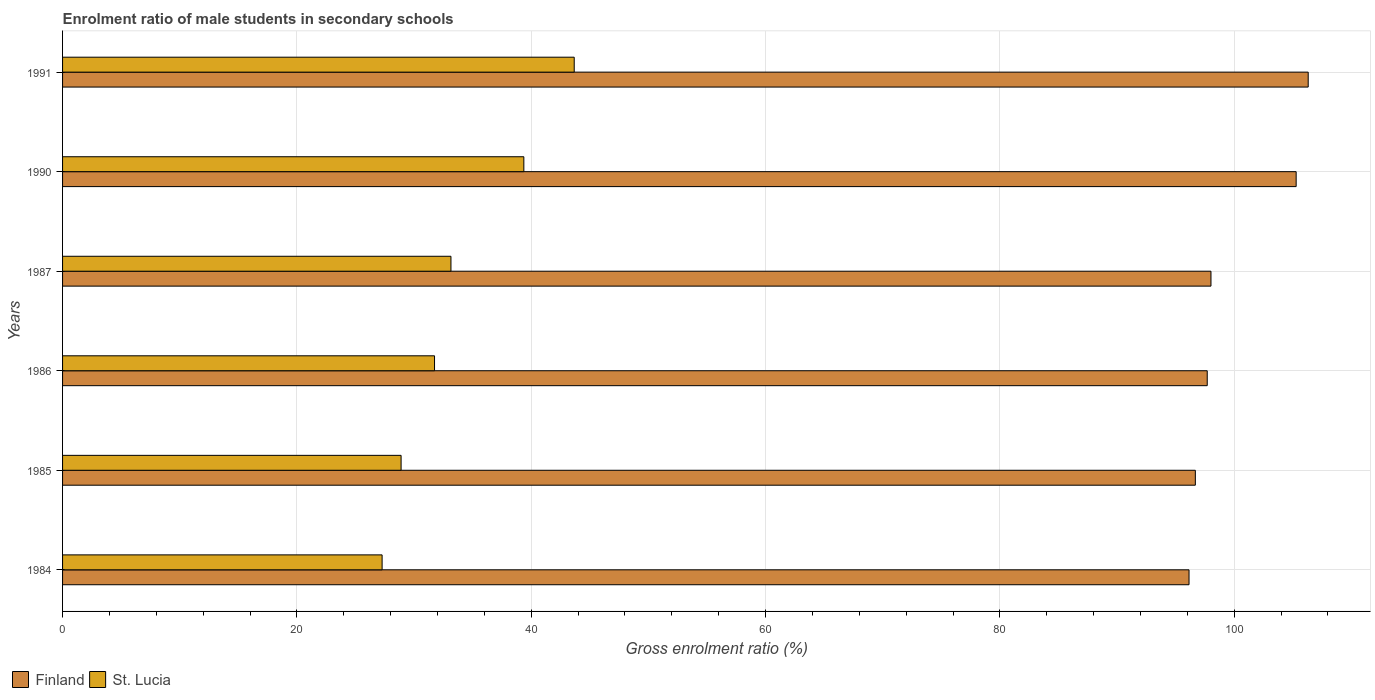How many different coloured bars are there?
Keep it short and to the point. 2. How many groups of bars are there?
Provide a short and direct response. 6. How many bars are there on the 5th tick from the top?
Ensure brevity in your answer.  2. How many bars are there on the 5th tick from the bottom?
Provide a succinct answer. 2. What is the enrolment ratio of male students in secondary schools in St. Lucia in 1990?
Provide a succinct answer. 39.37. Across all years, what is the maximum enrolment ratio of male students in secondary schools in St. Lucia?
Keep it short and to the point. 43.67. Across all years, what is the minimum enrolment ratio of male students in secondary schools in Finland?
Give a very brief answer. 96.14. In which year was the enrolment ratio of male students in secondary schools in Finland minimum?
Provide a short and direct response. 1984. What is the total enrolment ratio of male students in secondary schools in St. Lucia in the graph?
Your answer should be compact. 204.1. What is the difference between the enrolment ratio of male students in secondary schools in Finland in 1984 and that in 1985?
Your answer should be very brief. -0.54. What is the difference between the enrolment ratio of male students in secondary schools in St. Lucia in 1991 and the enrolment ratio of male students in secondary schools in Finland in 1985?
Ensure brevity in your answer.  -53.01. What is the average enrolment ratio of male students in secondary schools in St. Lucia per year?
Make the answer very short. 34.02. In the year 1985, what is the difference between the enrolment ratio of male students in secondary schools in St. Lucia and enrolment ratio of male students in secondary schools in Finland?
Make the answer very short. -67.79. In how many years, is the enrolment ratio of male students in secondary schools in Finland greater than 20 %?
Give a very brief answer. 6. What is the ratio of the enrolment ratio of male students in secondary schools in St. Lucia in 1985 to that in 1990?
Ensure brevity in your answer.  0.73. Is the enrolment ratio of male students in secondary schools in St. Lucia in 1986 less than that in 1991?
Ensure brevity in your answer.  Yes. What is the difference between the highest and the second highest enrolment ratio of male students in secondary schools in St. Lucia?
Keep it short and to the point. 4.3. What is the difference between the highest and the lowest enrolment ratio of male students in secondary schools in St. Lucia?
Provide a succinct answer. 16.4. In how many years, is the enrolment ratio of male students in secondary schools in Finland greater than the average enrolment ratio of male students in secondary schools in Finland taken over all years?
Your response must be concise. 2. Is the sum of the enrolment ratio of male students in secondary schools in Finland in 1984 and 1991 greater than the maximum enrolment ratio of male students in secondary schools in St. Lucia across all years?
Your answer should be compact. Yes. What does the 1st bar from the top in 1986 represents?
Your answer should be very brief. St. Lucia. What does the 2nd bar from the bottom in 1985 represents?
Offer a very short reply. St. Lucia. How many years are there in the graph?
Offer a terse response. 6. Does the graph contain any zero values?
Keep it short and to the point. No. Where does the legend appear in the graph?
Offer a terse response. Bottom left. What is the title of the graph?
Make the answer very short. Enrolment ratio of male students in secondary schools. What is the label or title of the Y-axis?
Ensure brevity in your answer.  Years. What is the Gross enrolment ratio (%) in Finland in 1984?
Keep it short and to the point. 96.14. What is the Gross enrolment ratio (%) in St. Lucia in 1984?
Offer a very short reply. 27.27. What is the Gross enrolment ratio (%) in Finland in 1985?
Provide a short and direct response. 96.68. What is the Gross enrolment ratio (%) in St. Lucia in 1985?
Make the answer very short. 28.89. What is the Gross enrolment ratio (%) in Finland in 1986?
Provide a succinct answer. 97.7. What is the Gross enrolment ratio (%) of St. Lucia in 1986?
Make the answer very short. 31.75. What is the Gross enrolment ratio (%) in Finland in 1987?
Offer a terse response. 98.01. What is the Gross enrolment ratio (%) of St. Lucia in 1987?
Your answer should be very brief. 33.15. What is the Gross enrolment ratio (%) of Finland in 1990?
Make the answer very short. 105.29. What is the Gross enrolment ratio (%) of St. Lucia in 1990?
Your answer should be compact. 39.37. What is the Gross enrolment ratio (%) in Finland in 1991?
Offer a very short reply. 106.31. What is the Gross enrolment ratio (%) in St. Lucia in 1991?
Ensure brevity in your answer.  43.67. Across all years, what is the maximum Gross enrolment ratio (%) in Finland?
Keep it short and to the point. 106.31. Across all years, what is the maximum Gross enrolment ratio (%) of St. Lucia?
Your answer should be compact. 43.67. Across all years, what is the minimum Gross enrolment ratio (%) of Finland?
Keep it short and to the point. 96.14. Across all years, what is the minimum Gross enrolment ratio (%) in St. Lucia?
Your answer should be compact. 27.27. What is the total Gross enrolment ratio (%) in Finland in the graph?
Offer a terse response. 600.13. What is the total Gross enrolment ratio (%) of St. Lucia in the graph?
Your answer should be compact. 204.1. What is the difference between the Gross enrolment ratio (%) in Finland in 1984 and that in 1985?
Your response must be concise. -0.54. What is the difference between the Gross enrolment ratio (%) of St. Lucia in 1984 and that in 1985?
Your answer should be very brief. -1.62. What is the difference between the Gross enrolment ratio (%) in Finland in 1984 and that in 1986?
Keep it short and to the point. -1.55. What is the difference between the Gross enrolment ratio (%) in St. Lucia in 1984 and that in 1986?
Provide a succinct answer. -4.47. What is the difference between the Gross enrolment ratio (%) in Finland in 1984 and that in 1987?
Give a very brief answer. -1.87. What is the difference between the Gross enrolment ratio (%) in St. Lucia in 1984 and that in 1987?
Provide a succinct answer. -5.88. What is the difference between the Gross enrolment ratio (%) in Finland in 1984 and that in 1990?
Ensure brevity in your answer.  -9.14. What is the difference between the Gross enrolment ratio (%) in St. Lucia in 1984 and that in 1990?
Provide a succinct answer. -12.1. What is the difference between the Gross enrolment ratio (%) in Finland in 1984 and that in 1991?
Give a very brief answer. -10.17. What is the difference between the Gross enrolment ratio (%) of St. Lucia in 1984 and that in 1991?
Your answer should be very brief. -16.4. What is the difference between the Gross enrolment ratio (%) of Finland in 1985 and that in 1986?
Provide a short and direct response. -1.02. What is the difference between the Gross enrolment ratio (%) in St. Lucia in 1985 and that in 1986?
Keep it short and to the point. -2.85. What is the difference between the Gross enrolment ratio (%) of Finland in 1985 and that in 1987?
Keep it short and to the point. -1.33. What is the difference between the Gross enrolment ratio (%) of St. Lucia in 1985 and that in 1987?
Ensure brevity in your answer.  -4.25. What is the difference between the Gross enrolment ratio (%) in Finland in 1985 and that in 1990?
Your response must be concise. -8.6. What is the difference between the Gross enrolment ratio (%) in St. Lucia in 1985 and that in 1990?
Provide a short and direct response. -10.48. What is the difference between the Gross enrolment ratio (%) of Finland in 1985 and that in 1991?
Offer a very short reply. -9.63. What is the difference between the Gross enrolment ratio (%) of St. Lucia in 1985 and that in 1991?
Give a very brief answer. -14.78. What is the difference between the Gross enrolment ratio (%) in Finland in 1986 and that in 1987?
Your answer should be compact. -0.32. What is the difference between the Gross enrolment ratio (%) of St. Lucia in 1986 and that in 1987?
Make the answer very short. -1.4. What is the difference between the Gross enrolment ratio (%) in Finland in 1986 and that in 1990?
Make the answer very short. -7.59. What is the difference between the Gross enrolment ratio (%) of St. Lucia in 1986 and that in 1990?
Make the answer very short. -7.62. What is the difference between the Gross enrolment ratio (%) in Finland in 1986 and that in 1991?
Your response must be concise. -8.62. What is the difference between the Gross enrolment ratio (%) in St. Lucia in 1986 and that in 1991?
Your answer should be compact. -11.92. What is the difference between the Gross enrolment ratio (%) of Finland in 1987 and that in 1990?
Make the answer very short. -7.27. What is the difference between the Gross enrolment ratio (%) in St. Lucia in 1987 and that in 1990?
Offer a very short reply. -6.22. What is the difference between the Gross enrolment ratio (%) in Finland in 1987 and that in 1991?
Your answer should be compact. -8.3. What is the difference between the Gross enrolment ratio (%) in St. Lucia in 1987 and that in 1991?
Make the answer very short. -10.52. What is the difference between the Gross enrolment ratio (%) in Finland in 1990 and that in 1991?
Give a very brief answer. -1.03. What is the difference between the Gross enrolment ratio (%) in St. Lucia in 1990 and that in 1991?
Make the answer very short. -4.3. What is the difference between the Gross enrolment ratio (%) of Finland in 1984 and the Gross enrolment ratio (%) of St. Lucia in 1985?
Provide a succinct answer. 67.25. What is the difference between the Gross enrolment ratio (%) in Finland in 1984 and the Gross enrolment ratio (%) in St. Lucia in 1986?
Offer a terse response. 64.4. What is the difference between the Gross enrolment ratio (%) of Finland in 1984 and the Gross enrolment ratio (%) of St. Lucia in 1987?
Your answer should be very brief. 62.99. What is the difference between the Gross enrolment ratio (%) of Finland in 1984 and the Gross enrolment ratio (%) of St. Lucia in 1990?
Provide a short and direct response. 56.77. What is the difference between the Gross enrolment ratio (%) in Finland in 1984 and the Gross enrolment ratio (%) in St. Lucia in 1991?
Ensure brevity in your answer.  52.47. What is the difference between the Gross enrolment ratio (%) of Finland in 1985 and the Gross enrolment ratio (%) of St. Lucia in 1986?
Your response must be concise. 64.93. What is the difference between the Gross enrolment ratio (%) in Finland in 1985 and the Gross enrolment ratio (%) in St. Lucia in 1987?
Keep it short and to the point. 63.53. What is the difference between the Gross enrolment ratio (%) of Finland in 1985 and the Gross enrolment ratio (%) of St. Lucia in 1990?
Your answer should be very brief. 57.31. What is the difference between the Gross enrolment ratio (%) in Finland in 1985 and the Gross enrolment ratio (%) in St. Lucia in 1991?
Offer a very short reply. 53.01. What is the difference between the Gross enrolment ratio (%) in Finland in 1986 and the Gross enrolment ratio (%) in St. Lucia in 1987?
Ensure brevity in your answer.  64.55. What is the difference between the Gross enrolment ratio (%) of Finland in 1986 and the Gross enrolment ratio (%) of St. Lucia in 1990?
Give a very brief answer. 58.33. What is the difference between the Gross enrolment ratio (%) in Finland in 1986 and the Gross enrolment ratio (%) in St. Lucia in 1991?
Your response must be concise. 54.03. What is the difference between the Gross enrolment ratio (%) of Finland in 1987 and the Gross enrolment ratio (%) of St. Lucia in 1990?
Keep it short and to the point. 58.64. What is the difference between the Gross enrolment ratio (%) in Finland in 1987 and the Gross enrolment ratio (%) in St. Lucia in 1991?
Provide a succinct answer. 54.35. What is the difference between the Gross enrolment ratio (%) of Finland in 1990 and the Gross enrolment ratio (%) of St. Lucia in 1991?
Give a very brief answer. 61.62. What is the average Gross enrolment ratio (%) of Finland per year?
Offer a terse response. 100.02. What is the average Gross enrolment ratio (%) in St. Lucia per year?
Ensure brevity in your answer.  34.02. In the year 1984, what is the difference between the Gross enrolment ratio (%) of Finland and Gross enrolment ratio (%) of St. Lucia?
Your answer should be compact. 68.87. In the year 1985, what is the difference between the Gross enrolment ratio (%) of Finland and Gross enrolment ratio (%) of St. Lucia?
Provide a succinct answer. 67.79. In the year 1986, what is the difference between the Gross enrolment ratio (%) of Finland and Gross enrolment ratio (%) of St. Lucia?
Provide a succinct answer. 65.95. In the year 1987, what is the difference between the Gross enrolment ratio (%) in Finland and Gross enrolment ratio (%) in St. Lucia?
Keep it short and to the point. 64.87. In the year 1990, what is the difference between the Gross enrolment ratio (%) of Finland and Gross enrolment ratio (%) of St. Lucia?
Keep it short and to the point. 65.92. In the year 1991, what is the difference between the Gross enrolment ratio (%) of Finland and Gross enrolment ratio (%) of St. Lucia?
Offer a terse response. 62.65. What is the ratio of the Gross enrolment ratio (%) of St. Lucia in 1984 to that in 1985?
Give a very brief answer. 0.94. What is the ratio of the Gross enrolment ratio (%) in Finland in 1984 to that in 1986?
Provide a succinct answer. 0.98. What is the ratio of the Gross enrolment ratio (%) of St. Lucia in 1984 to that in 1986?
Provide a short and direct response. 0.86. What is the ratio of the Gross enrolment ratio (%) in Finland in 1984 to that in 1987?
Give a very brief answer. 0.98. What is the ratio of the Gross enrolment ratio (%) in St. Lucia in 1984 to that in 1987?
Offer a terse response. 0.82. What is the ratio of the Gross enrolment ratio (%) of Finland in 1984 to that in 1990?
Ensure brevity in your answer.  0.91. What is the ratio of the Gross enrolment ratio (%) in St. Lucia in 1984 to that in 1990?
Provide a short and direct response. 0.69. What is the ratio of the Gross enrolment ratio (%) in Finland in 1984 to that in 1991?
Give a very brief answer. 0.9. What is the ratio of the Gross enrolment ratio (%) of St. Lucia in 1984 to that in 1991?
Offer a terse response. 0.62. What is the ratio of the Gross enrolment ratio (%) in St. Lucia in 1985 to that in 1986?
Make the answer very short. 0.91. What is the ratio of the Gross enrolment ratio (%) of Finland in 1985 to that in 1987?
Give a very brief answer. 0.99. What is the ratio of the Gross enrolment ratio (%) in St. Lucia in 1985 to that in 1987?
Offer a very short reply. 0.87. What is the ratio of the Gross enrolment ratio (%) of Finland in 1985 to that in 1990?
Your answer should be very brief. 0.92. What is the ratio of the Gross enrolment ratio (%) of St. Lucia in 1985 to that in 1990?
Your response must be concise. 0.73. What is the ratio of the Gross enrolment ratio (%) in Finland in 1985 to that in 1991?
Give a very brief answer. 0.91. What is the ratio of the Gross enrolment ratio (%) of St. Lucia in 1985 to that in 1991?
Make the answer very short. 0.66. What is the ratio of the Gross enrolment ratio (%) in St. Lucia in 1986 to that in 1987?
Your answer should be compact. 0.96. What is the ratio of the Gross enrolment ratio (%) in Finland in 1986 to that in 1990?
Ensure brevity in your answer.  0.93. What is the ratio of the Gross enrolment ratio (%) in St. Lucia in 1986 to that in 1990?
Offer a very short reply. 0.81. What is the ratio of the Gross enrolment ratio (%) of Finland in 1986 to that in 1991?
Give a very brief answer. 0.92. What is the ratio of the Gross enrolment ratio (%) of St. Lucia in 1986 to that in 1991?
Keep it short and to the point. 0.73. What is the ratio of the Gross enrolment ratio (%) in Finland in 1987 to that in 1990?
Keep it short and to the point. 0.93. What is the ratio of the Gross enrolment ratio (%) of St. Lucia in 1987 to that in 1990?
Your response must be concise. 0.84. What is the ratio of the Gross enrolment ratio (%) of Finland in 1987 to that in 1991?
Your answer should be compact. 0.92. What is the ratio of the Gross enrolment ratio (%) in St. Lucia in 1987 to that in 1991?
Your answer should be very brief. 0.76. What is the ratio of the Gross enrolment ratio (%) of Finland in 1990 to that in 1991?
Offer a terse response. 0.99. What is the ratio of the Gross enrolment ratio (%) in St. Lucia in 1990 to that in 1991?
Your answer should be compact. 0.9. What is the difference between the highest and the second highest Gross enrolment ratio (%) in Finland?
Your answer should be compact. 1.03. What is the difference between the highest and the second highest Gross enrolment ratio (%) of St. Lucia?
Your response must be concise. 4.3. What is the difference between the highest and the lowest Gross enrolment ratio (%) of Finland?
Offer a terse response. 10.17. What is the difference between the highest and the lowest Gross enrolment ratio (%) of St. Lucia?
Ensure brevity in your answer.  16.4. 